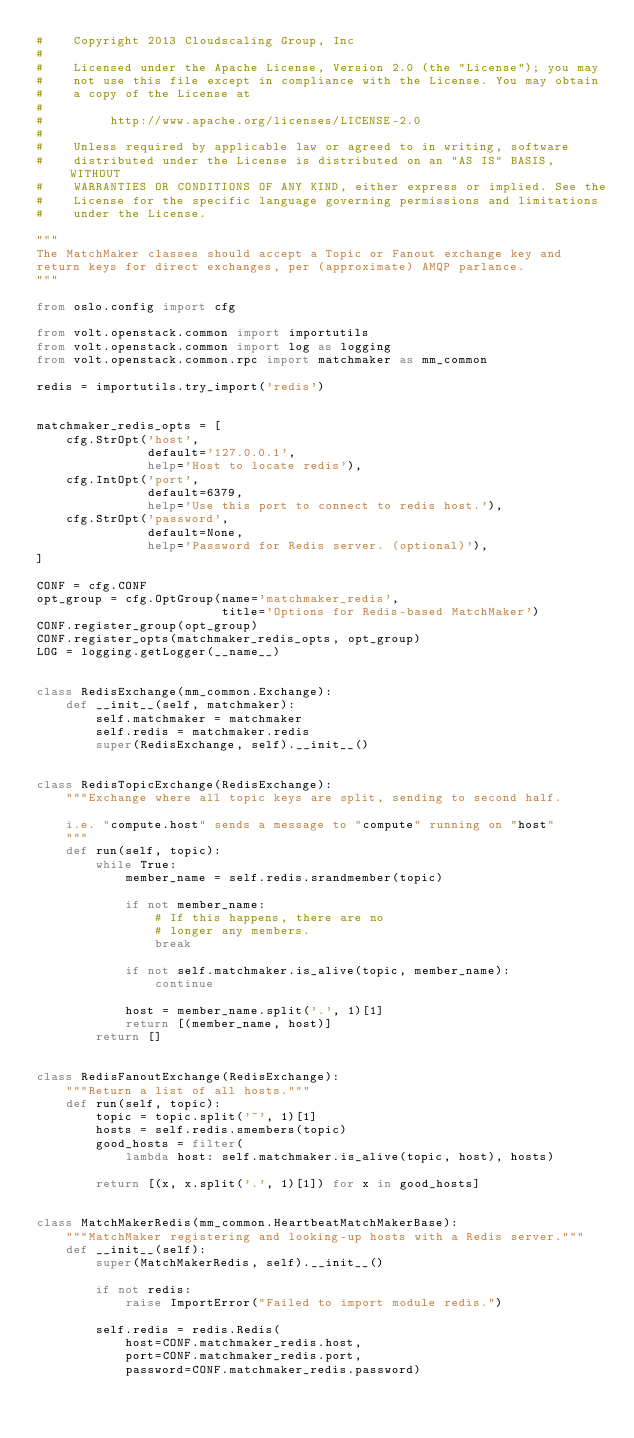Convert code to text. <code><loc_0><loc_0><loc_500><loc_500><_Python_>#    Copyright 2013 Cloudscaling Group, Inc
#
#    Licensed under the Apache License, Version 2.0 (the "License"); you may
#    not use this file except in compliance with the License. You may obtain
#    a copy of the License at
#
#         http://www.apache.org/licenses/LICENSE-2.0
#
#    Unless required by applicable law or agreed to in writing, software
#    distributed under the License is distributed on an "AS IS" BASIS, WITHOUT
#    WARRANTIES OR CONDITIONS OF ANY KIND, either express or implied. See the
#    License for the specific language governing permissions and limitations
#    under the License.

"""
The MatchMaker classes should accept a Topic or Fanout exchange key and
return keys for direct exchanges, per (approximate) AMQP parlance.
"""

from oslo.config import cfg

from volt.openstack.common import importutils
from volt.openstack.common import log as logging
from volt.openstack.common.rpc import matchmaker as mm_common

redis = importutils.try_import('redis')


matchmaker_redis_opts = [
    cfg.StrOpt('host',
               default='127.0.0.1',
               help='Host to locate redis'),
    cfg.IntOpt('port',
               default=6379,
               help='Use this port to connect to redis host.'),
    cfg.StrOpt('password',
               default=None,
               help='Password for Redis server. (optional)'),
]

CONF = cfg.CONF
opt_group = cfg.OptGroup(name='matchmaker_redis',
                         title='Options for Redis-based MatchMaker')
CONF.register_group(opt_group)
CONF.register_opts(matchmaker_redis_opts, opt_group)
LOG = logging.getLogger(__name__)


class RedisExchange(mm_common.Exchange):
    def __init__(self, matchmaker):
        self.matchmaker = matchmaker
        self.redis = matchmaker.redis
        super(RedisExchange, self).__init__()


class RedisTopicExchange(RedisExchange):
    """Exchange where all topic keys are split, sending to second half.

    i.e. "compute.host" sends a message to "compute" running on "host"
    """
    def run(self, topic):
        while True:
            member_name = self.redis.srandmember(topic)

            if not member_name:
                # If this happens, there are no
                # longer any members.
                break

            if not self.matchmaker.is_alive(topic, member_name):
                continue

            host = member_name.split('.', 1)[1]
            return [(member_name, host)]
        return []


class RedisFanoutExchange(RedisExchange):
    """Return a list of all hosts."""
    def run(self, topic):
        topic = topic.split('~', 1)[1]
        hosts = self.redis.smembers(topic)
        good_hosts = filter(
            lambda host: self.matchmaker.is_alive(topic, host), hosts)

        return [(x, x.split('.', 1)[1]) for x in good_hosts]


class MatchMakerRedis(mm_common.HeartbeatMatchMakerBase):
    """MatchMaker registering and looking-up hosts with a Redis server."""
    def __init__(self):
        super(MatchMakerRedis, self).__init__()

        if not redis:
            raise ImportError("Failed to import module redis.")

        self.redis = redis.Redis(
            host=CONF.matchmaker_redis.host,
            port=CONF.matchmaker_redis.port,
            password=CONF.matchmaker_redis.password)
</code> 